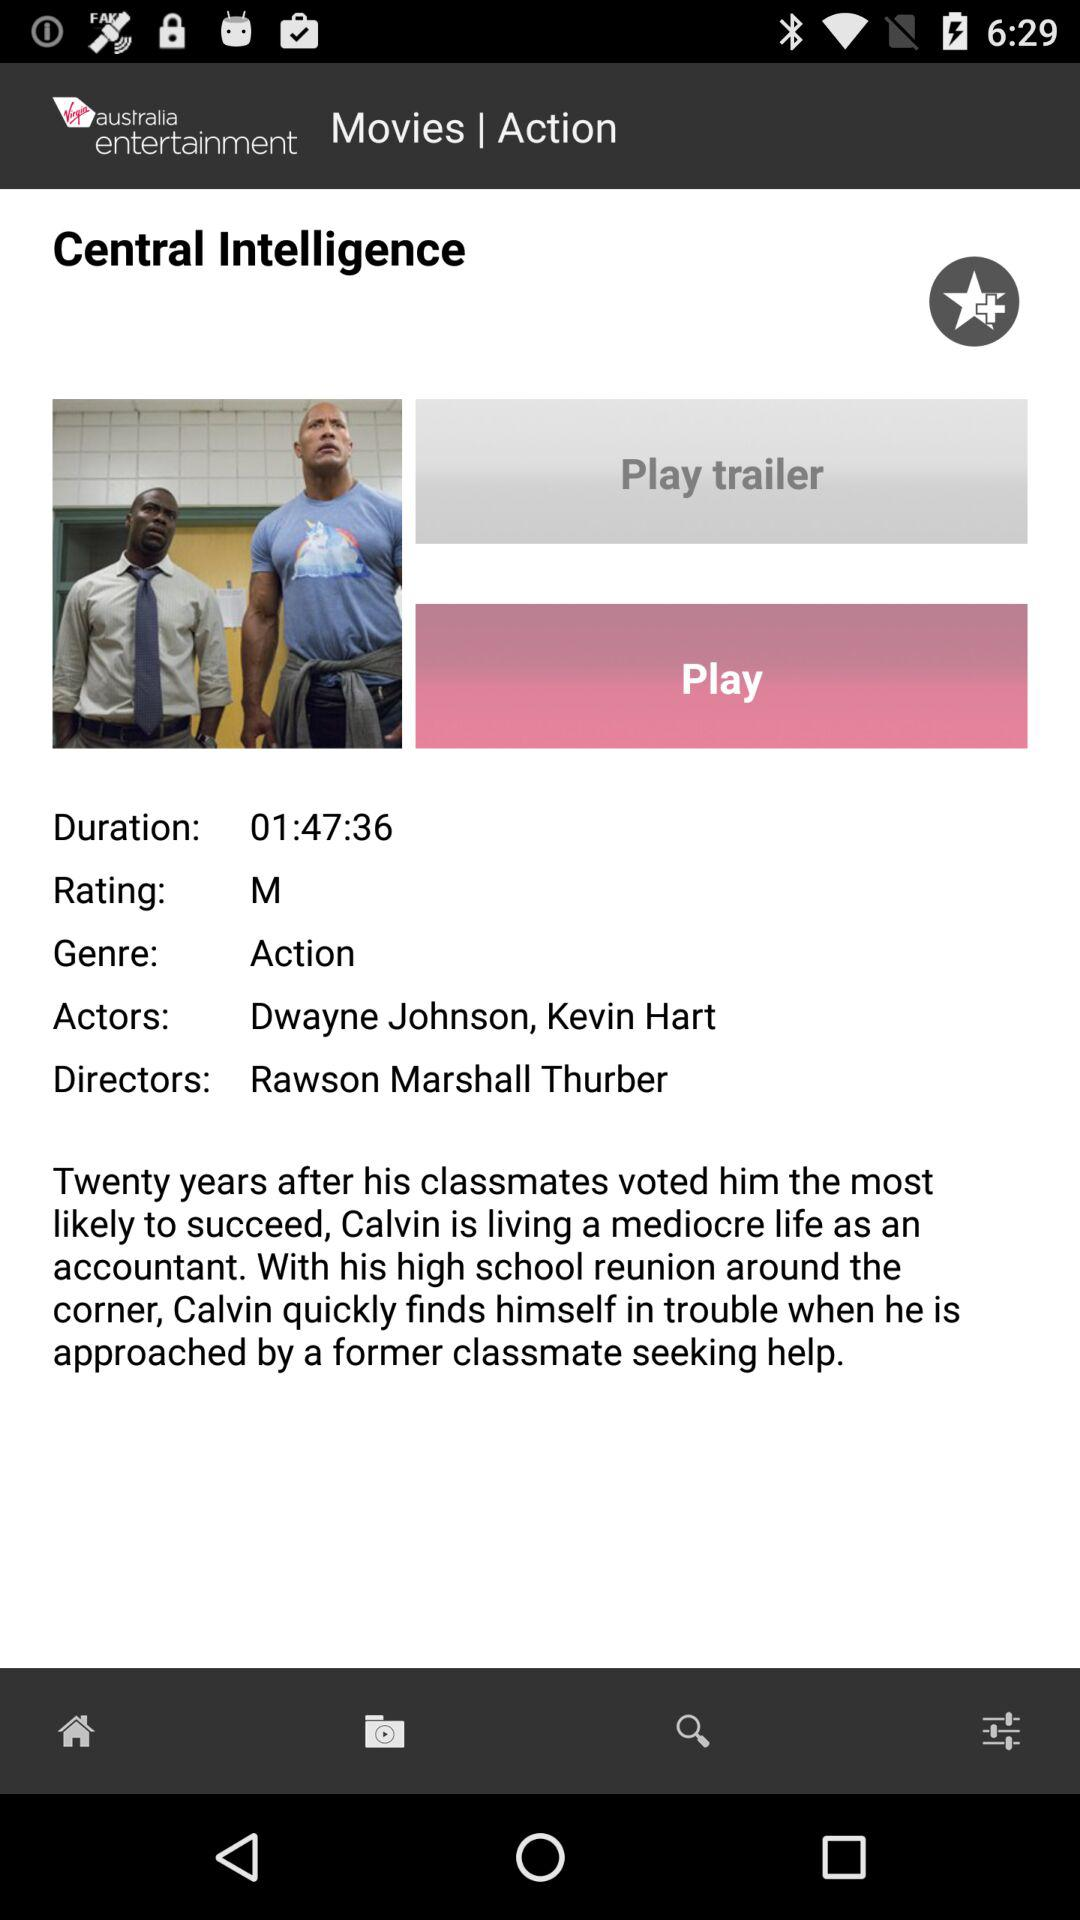What is the name of the director? The name of the director is Rawson Marshall Thurber. 